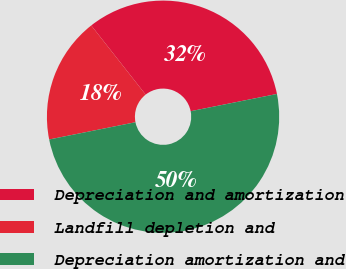Convert chart. <chart><loc_0><loc_0><loc_500><loc_500><pie_chart><fcel>Depreciation and amortization<fcel>Landfill depletion and<fcel>Depreciation amortization and<nl><fcel>32.47%<fcel>17.53%<fcel>50.0%<nl></chart> 